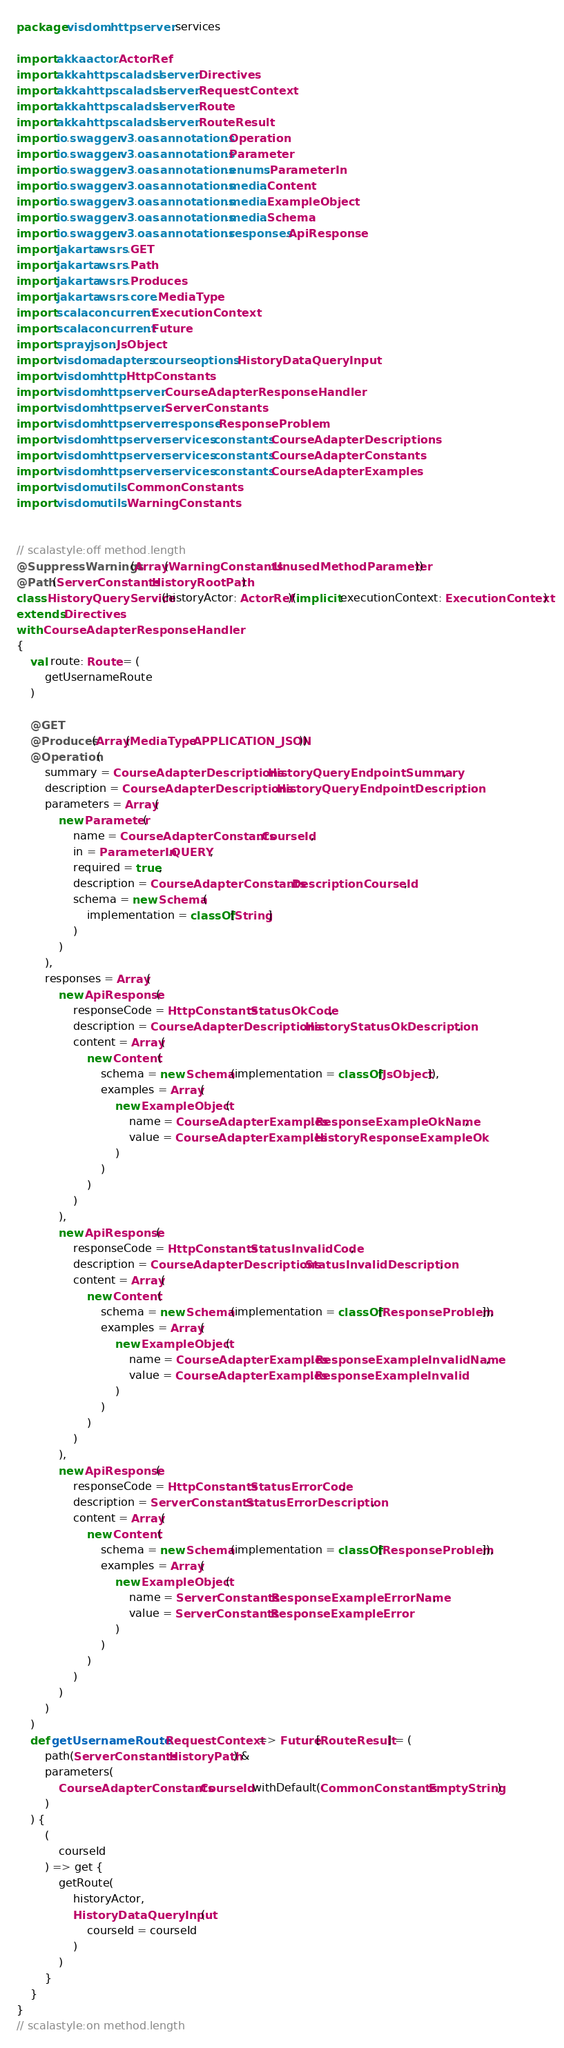<code> <loc_0><loc_0><loc_500><loc_500><_Scala_>package visdom.http.server.services

import akka.actor.ActorRef
import akka.http.scaladsl.server.Directives
import akka.http.scaladsl.server.RequestContext
import akka.http.scaladsl.server.Route
import akka.http.scaladsl.server.RouteResult
import io.swagger.v3.oas.annotations.Operation
import io.swagger.v3.oas.annotations.Parameter
import io.swagger.v3.oas.annotations.enums.ParameterIn
import io.swagger.v3.oas.annotations.media.Content
import io.swagger.v3.oas.annotations.media.ExampleObject
import io.swagger.v3.oas.annotations.media.Schema
import io.swagger.v3.oas.annotations.responses.ApiResponse
import jakarta.ws.rs.GET
import jakarta.ws.rs.Path
import jakarta.ws.rs.Produces
import jakarta.ws.rs.core.MediaType
import scala.concurrent.ExecutionContext
import scala.concurrent.Future
import spray.json.JsObject
import visdom.adapters.course.options.HistoryDataQueryInput
import visdom.http.HttpConstants
import visdom.http.server.CourseAdapterResponseHandler
import visdom.http.server.ServerConstants
import visdom.http.server.response.ResponseProblem
import visdom.http.server.services.constants.CourseAdapterDescriptions
import visdom.http.server.services.constants.CourseAdapterConstants
import visdom.http.server.services.constants.CourseAdapterExamples
import visdom.utils.CommonConstants
import visdom.utils.WarningConstants


// scalastyle:off method.length
@SuppressWarnings(Array(WarningConstants.UnusedMethodParameter))
@Path(ServerConstants.HistoryRootPath)
class HistoryQueryService(historyActor: ActorRef)(implicit executionContext: ExecutionContext)
extends Directives
with CourseAdapterResponseHandler
{
    val route: Route = (
        getUsernameRoute
    )

    @GET
    @Produces(Array(MediaType.APPLICATION_JSON))
    @Operation(
        summary = CourseAdapterDescriptions.HistoryQueryEndpointSummary,
        description = CourseAdapterDescriptions.HistoryQueryEndpointDescription,
        parameters = Array(
            new Parameter(
                name = CourseAdapterConstants.CourseId,
                in = ParameterIn.QUERY,
                required = true,
                description = CourseAdapterConstants.DescriptionCourseId,
                schema = new Schema(
                    implementation = classOf[String]
                )
            )
        ),
        responses = Array(
            new ApiResponse(
                responseCode = HttpConstants.StatusOkCode,
                description = CourseAdapterDescriptions.HistoryStatusOkDescription,
                content = Array(
                    new Content(
                        schema = new Schema(implementation = classOf[JsObject]),
                        examples = Array(
                            new ExampleObject(
                                name = CourseAdapterExamples.ResponseExampleOkName,
                                value = CourseAdapterExamples.HistoryResponseExampleOk
                            )
                        )
                    )
                )
            ),
            new ApiResponse(
                responseCode = HttpConstants.StatusInvalidCode,
                description = CourseAdapterDescriptions.StatusInvalidDescription,
                content = Array(
                    new Content(
                        schema = new Schema(implementation = classOf[ResponseProblem]),
                        examples = Array(
                            new ExampleObject(
                                name = CourseAdapterExamples.ResponseExampleInvalidName,
                                value = CourseAdapterExamples.ResponseExampleInvalid
                            )
                        )
                    )
                )
            ),
            new ApiResponse(
                responseCode = HttpConstants.StatusErrorCode,
                description = ServerConstants.StatusErrorDescription,
                content = Array(
                    new Content(
                        schema = new Schema(implementation = classOf[ResponseProblem]),
                        examples = Array(
                            new ExampleObject(
                                name = ServerConstants.ResponseExampleErrorName,
                                value = ServerConstants.ResponseExampleError
                            )
                        )
                    )
                )
            )
        )
    )
    def getUsernameRoute: RequestContext => Future[RouteResult] = (
        path(ServerConstants.HistoryPath) &
        parameters(
            CourseAdapterConstants.CourseId.withDefault(CommonConstants.EmptyString)
        )
    ) {
        (
            courseId
        ) => get {
            getRoute(
                historyActor,
                HistoryDataQueryInput(
                    courseId = courseId
                )
            )
        }
    }
}
// scalastyle:on method.length
</code> 